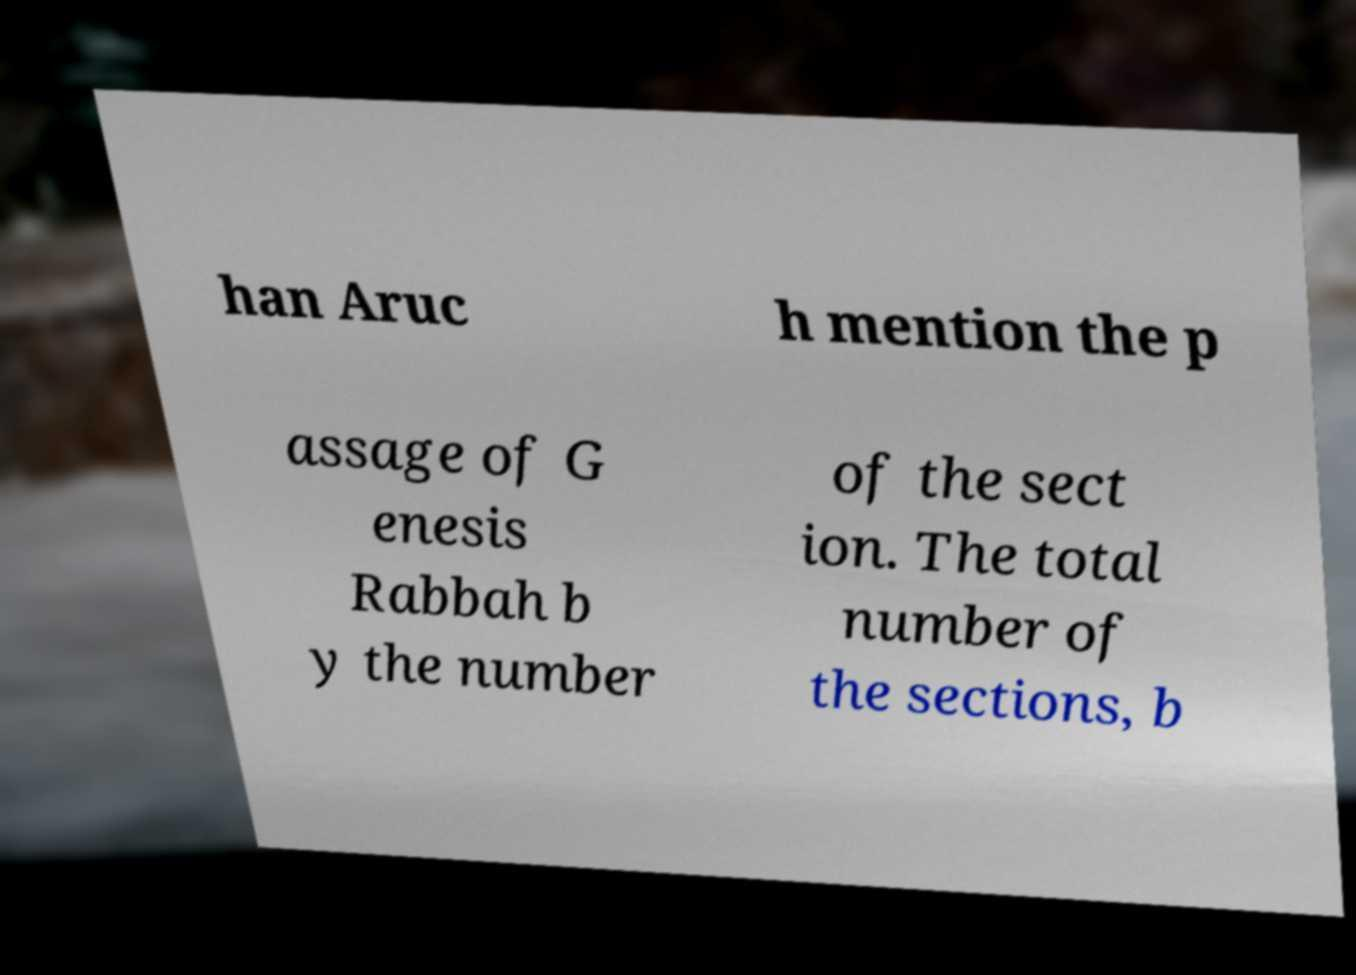What messages or text are displayed in this image? I need them in a readable, typed format. han Aruc h mention the p assage of G enesis Rabbah b y the number of the sect ion. The total number of the sections, b 